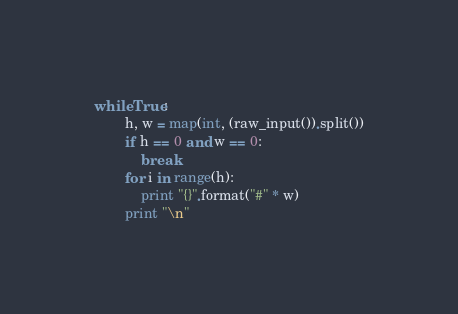Convert code to text. <code><loc_0><loc_0><loc_500><loc_500><_Python_>while True:
        h, w = map(int, (raw_input()).split())
        if h == 0 and w == 0:
            break
        for i in range(h):
            print "{}".format("#" * w)
        print "\n"</code> 